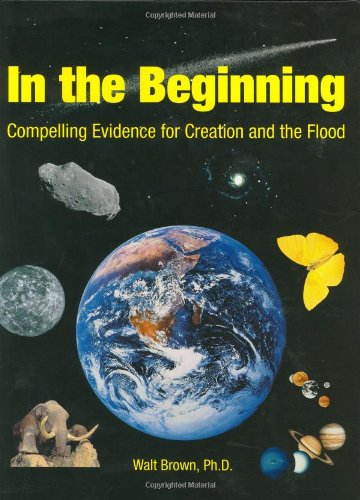Could you tell me more about the scientific arguments presented in this book? The book delves into various scientific arguments supporting a creationist view of Earth's history, discussing geological and biological evidences that the author interprets as consistent with biblical texts. 